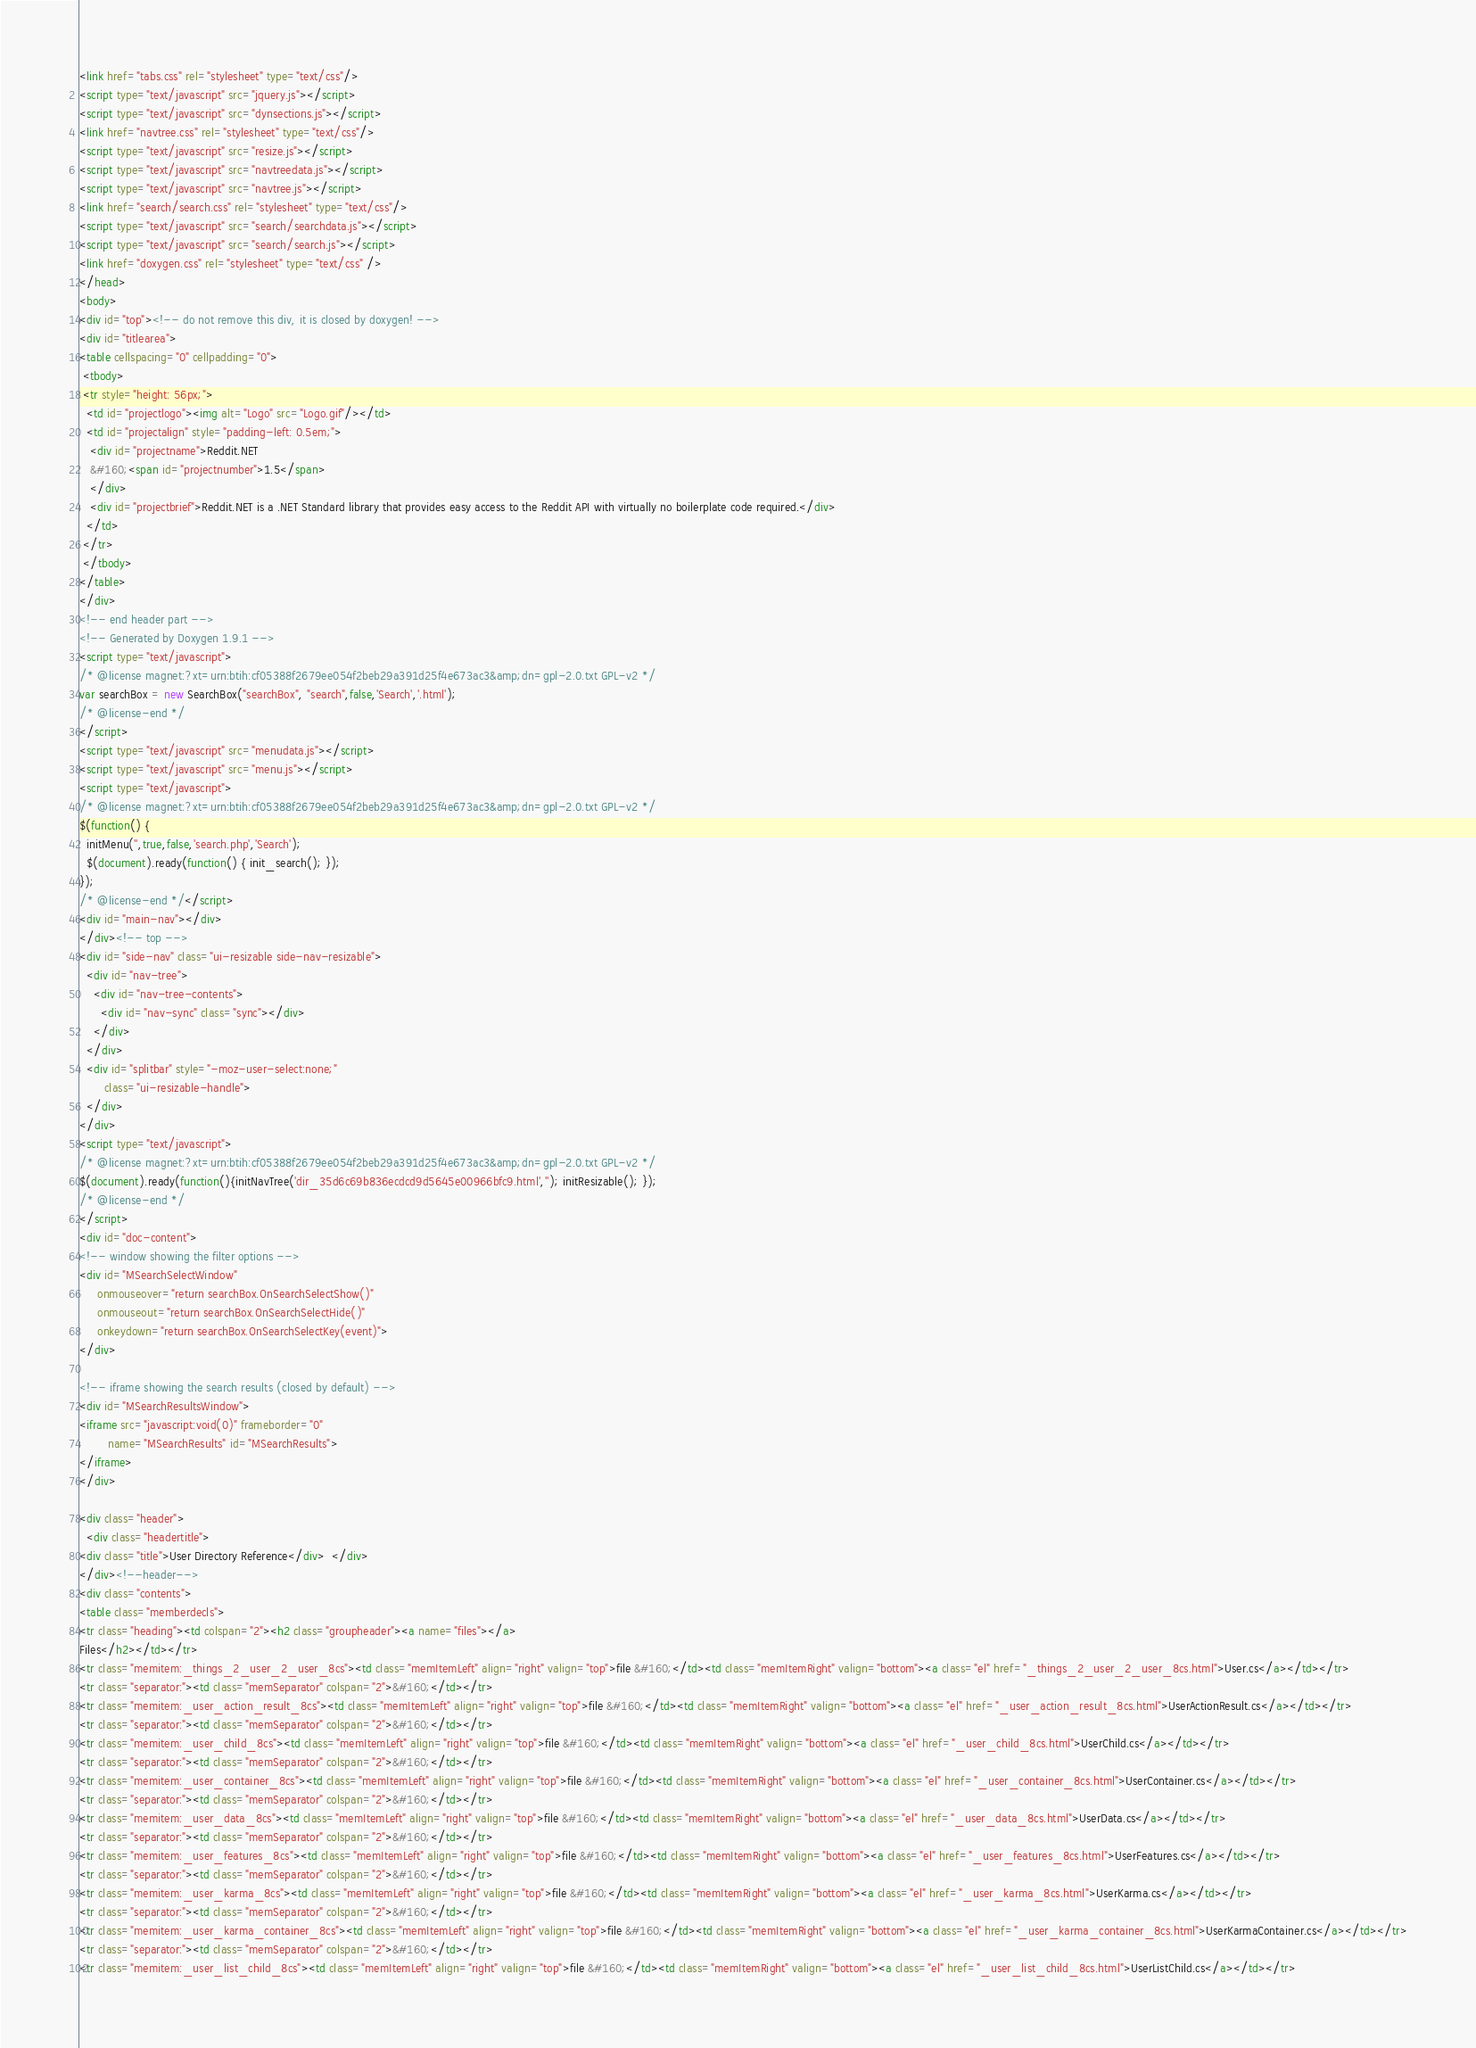<code> <loc_0><loc_0><loc_500><loc_500><_HTML_><link href="tabs.css" rel="stylesheet" type="text/css"/>
<script type="text/javascript" src="jquery.js"></script>
<script type="text/javascript" src="dynsections.js"></script>
<link href="navtree.css" rel="stylesheet" type="text/css"/>
<script type="text/javascript" src="resize.js"></script>
<script type="text/javascript" src="navtreedata.js"></script>
<script type="text/javascript" src="navtree.js"></script>
<link href="search/search.css" rel="stylesheet" type="text/css"/>
<script type="text/javascript" src="search/searchdata.js"></script>
<script type="text/javascript" src="search/search.js"></script>
<link href="doxygen.css" rel="stylesheet" type="text/css" />
</head>
<body>
<div id="top"><!-- do not remove this div, it is closed by doxygen! -->
<div id="titlearea">
<table cellspacing="0" cellpadding="0">
 <tbody>
 <tr style="height: 56px;">
  <td id="projectlogo"><img alt="Logo" src="Logo.gif"/></td>
  <td id="projectalign" style="padding-left: 0.5em;">
   <div id="projectname">Reddit.NET
   &#160;<span id="projectnumber">1.5</span>
   </div>
   <div id="projectbrief">Reddit.NET is a .NET Standard library that provides easy access to the Reddit API with virtually no boilerplate code required.</div>
  </td>
 </tr>
 </tbody>
</table>
</div>
<!-- end header part -->
<!-- Generated by Doxygen 1.9.1 -->
<script type="text/javascript">
/* @license magnet:?xt=urn:btih:cf05388f2679ee054f2beb29a391d25f4e673ac3&amp;dn=gpl-2.0.txt GPL-v2 */
var searchBox = new SearchBox("searchBox", "search",false,'Search','.html');
/* @license-end */
</script>
<script type="text/javascript" src="menudata.js"></script>
<script type="text/javascript" src="menu.js"></script>
<script type="text/javascript">
/* @license magnet:?xt=urn:btih:cf05388f2679ee054f2beb29a391d25f4e673ac3&amp;dn=gpl-2.0.txt GPL-v2 */
$(function() {
  initMenu('',true,false,'search.php','Search');
  $(document).ready(function() { init_search(); });
});
/* @license-end */</script>
<div id="main-nav"></div>
</div><!-- top -->
<div id="side-nav" class="ui-resizable side-nav-resizable">
  <div id="nav-tree">
    <div id="nav-tree-contents">
      <div id="nav-sync" class="sync"></div>
    </div>
  </div>
  <div id="splitbar" style="-moz-user-select:none;" 
       class="ui-resizable-handle">
  </div>
</div>
<script type="text/javascript">
/* @license magnet:?xt=urn:btih:cf05388f2679ee054f2beb29a391d25f4e673ac3&amp;dn=gpl-2.0.txt GPL-v2 */
$(document).ready(function(){initNavTree('dir_35d6c69b836ecdcd9d5645e00966bfc9.html',''); initResizable(); });
/* @license-end */
</script>
<div id="doc-content">
<!-- window showing the filter options -->
<div id="MSearchSelectWindow"
     onmouseover="return searchBox.OnSearchSelectShow()"
     onmouseout="return searchBox.OnSearchSelectHide()"
     onkeydown="return searchBox.OnSearchSelectKey(event)">
</div>

<!-- iframe showing the search results (closed by default) -->
<div id="MSearchResultsWindow">
<iframe src="javascript:void(0)" frameborder="0" 
        name="MSearchResults" id="MSearchResults">
</iframe>
</div>

<div class="header">
  <div class="headertitle">
<div class="title">User Directory Reference</div>  </div>
</div><!--header-->
<div class="contents">
<table class="memberdecls">
<tr class="heading"><td colspan="2"><h2 class="groupheader"><a name="files"></a>
Files</h2></td></tr>
<tr class="memitem:_things_2_user_2_user_8cs"><td class="memItemLeft" align="right" valign="top">file &#160;</td><td class="memItemRight" valign="bottom"><a class="el" href="_things_2_user_2_user_8cs.html">User.cs</a></td></tr>
<tr class="separator:"><td class="memSeparator" colspan="2">&#160;</td></tr>
<tr class="memitem:_user_action_result_8cs"><td class="memItemLeft" align="right" valign="top">file &#160;</td><td class="memItemRight" valign="bottom"><a class="el" href="_user_action_result_8cs.html">UserActionResult.cs</a></td></tr>
<tr class="separator:"><td class="memSeparator" colspan="2">&#160;</td></tr>
<tr class="memitem:_user_child_8cs"><td class="memItemLeft" align="right" valign="top">file &#160;</td><td class="memItemRight" valign="bottom"><a class="el" href="_user_child_8cs.html">UserChild.cs</a></td></tr>
<tr class="separator:"><td class="memSeparator" colspan="2">&#160;</td></tr>
<tr class="memitem:_user_container_8cs"><td class="memItemLeft" align="right" valign="top">file &#160;</td><td class="memItemRight" valign="bottom"><a class="el" href="_user_container_8cs.html">UserContainer.cs</a></td></tr>
<tr class="separator:"><td class="memSeparator" colspan="2">&#160;</td></tr>
<tr class="memitem:_user_data_8cs"><td class="memItemLeft" align="right" valign="top">file &#160;</td><td class="memItemRight" valign="bottom"><a class="el" href="_user_data_8cs.html">UserData.cs</a></td></tr>
<tr class="separator:"><td class="memSeparator" colspan="2">&#160;</td></tr>
<tr class="memitem:_user_features_8cs"><td class="memItemLeft" align="right" valign="top">file &#160;</td><td class="memItemRight" valign="bottom"><a class="el" href="_user_features_8cs.html">UserFeatures.cs</a></td></tr>
<tr class="separator:"><td class="memSeparator" colspan="2">&#160;</td></tr>
<tr class="memitem:_user_karma_8cs"><td class="memItemLeft" align="right" valign="top">file &#160;</td><td class="memItemRight" valign="bottom"><a class="el" href="_user_karma_8cs.html">UserKarma.cs</a></td></tr>
<tr class="separator:"><td class="memSeparator" colspan="2">&#160;</td></tr>
<tr class="memitem:_user_karma_container_8cs"><td class="memItemLeft" align="right" valign="top">file &#160;</td><td class="memItemRight" valign="bottom"><a class="el" href="_user_karma_container_8cs.html">UserKarmaContainer.cs</a></td></tr>
<tr class="separator:"><td class="memSeparator" colspan="2">&#160;</td></tr>
<tr class="memitem:_user_list_child_8cs"><td class="memItemLeft" align="right" valign="top">file &#160;</td><td class="memItemRight" valign="bottom"><a class="el" href="_user_list_child_8cs.html">UserListChild.cs</a></td></tr></code> 